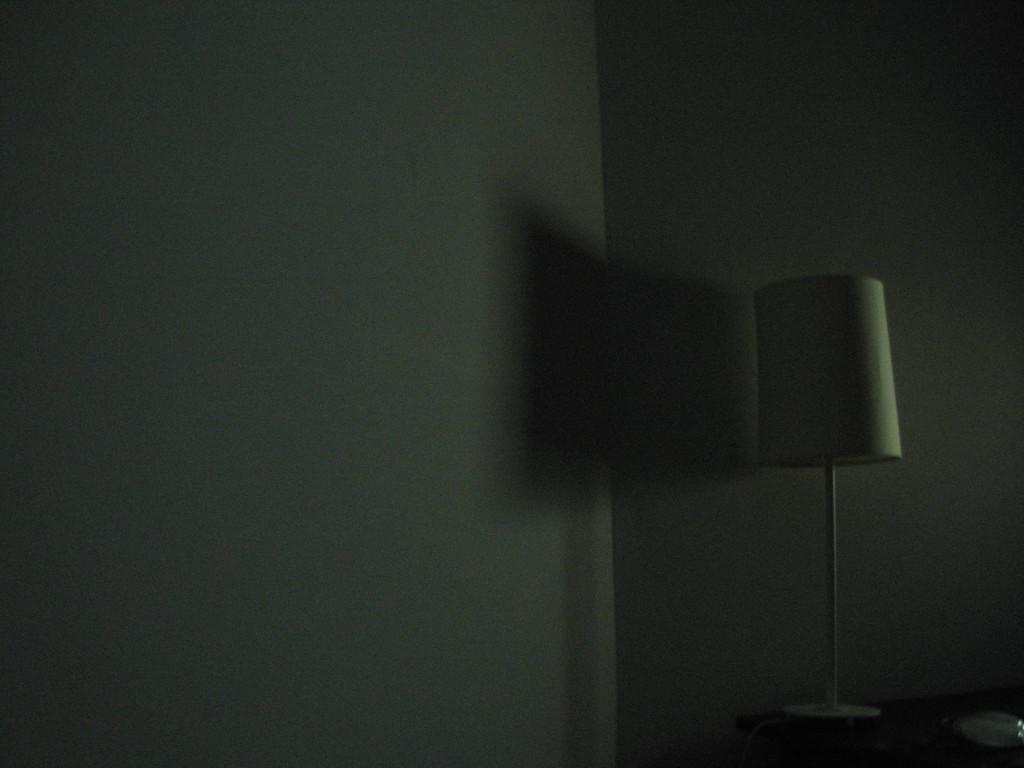Could you give a brief overview of what you see in this image? Here in this picture we can see a lamp present on the table over there. 